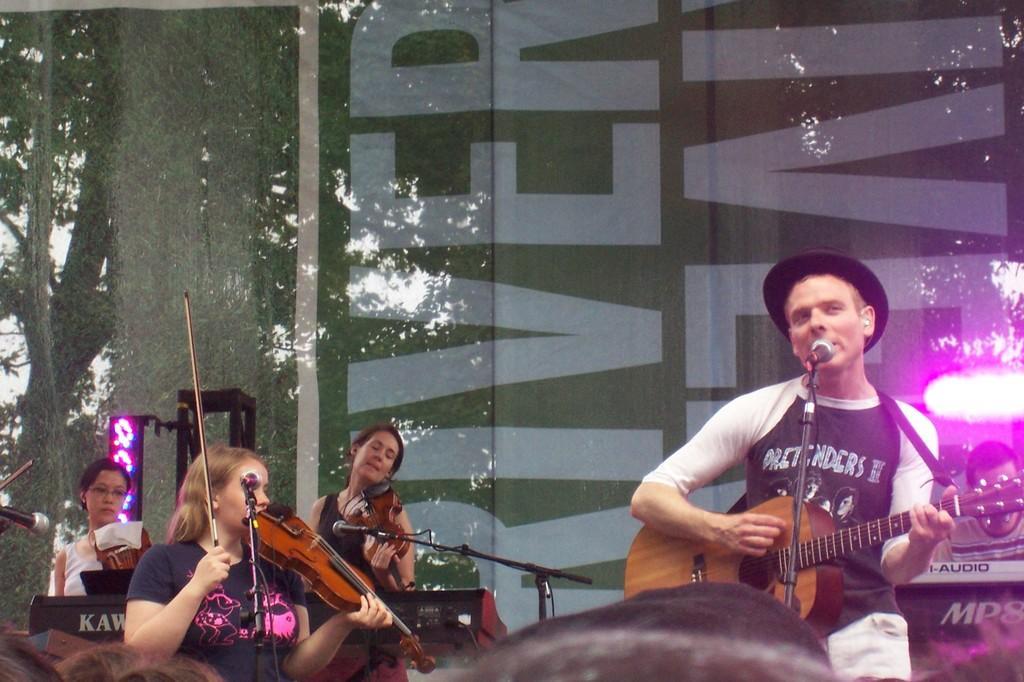How would you summarize this image in a sentence or two? The person wearing black hat is singing in front of a mic and playing guitar and there are three ladies playing violin beside him and there are group of audience in front of them. 